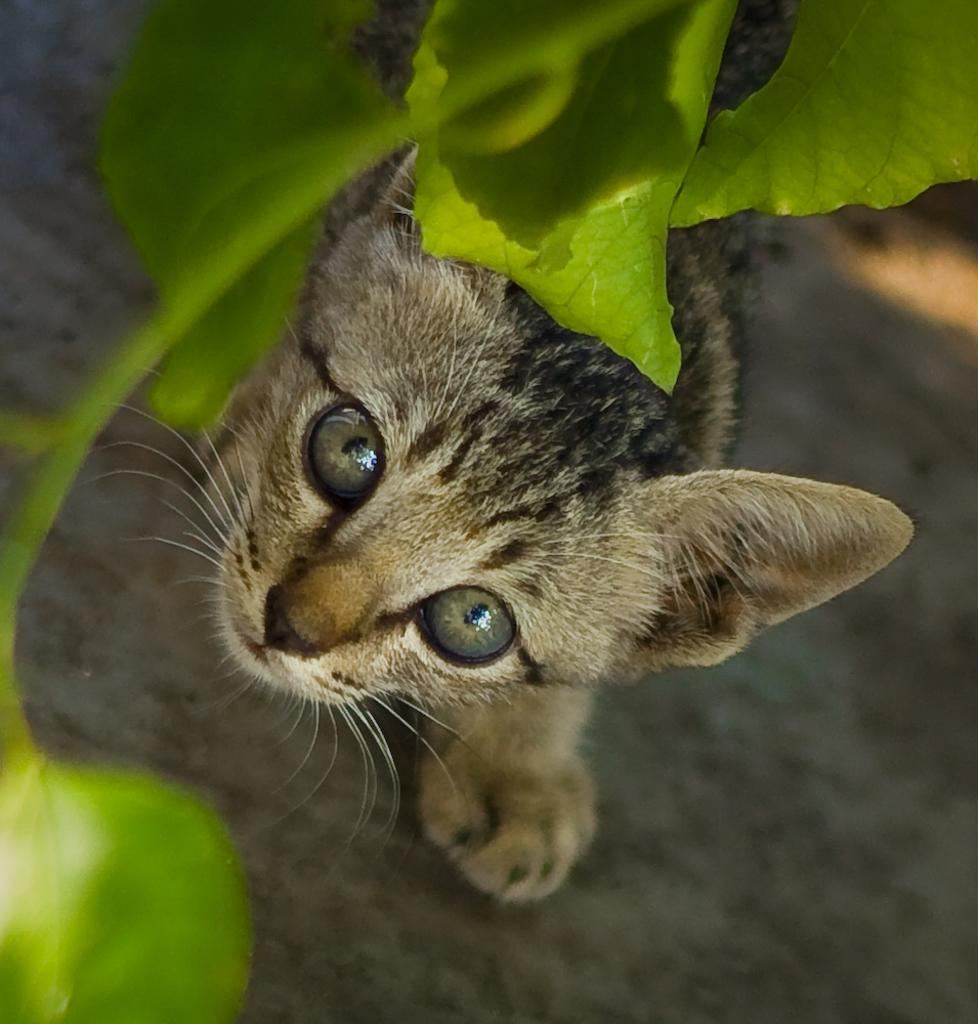What animal is present in the image? There is a cat in the image. Where is the cat located in the image? The cat is standing on the road. What is the cat looking at in the image? The cat is looking at leaves. How are the leaves positioned in relation to the cat? The leaves are in front of the cat. What type of brush is the cat using to smash the shoe in the image? There is no brush or shoe present in the image, and the cat is not smashing anything. 